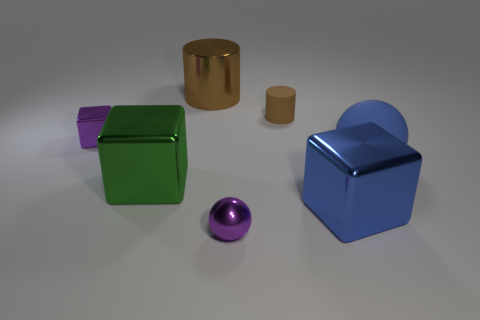Are there any purple cylinders of the same size as the shiny ball?
Your answer should be very brief. No. There is a big blue matte object; is its shape the same as the brown thing that is behind the tiny brown cylinder?
Provide a short and direct response. No. Is there a tiny cylinder to the left of the small shiny thing that is behind the ball that is to the left of the rubber cylinder?
Ensure brevity in your answer.  No. The green shiny block has what size?
Offer a very short reply. Large. What number of other things are there of the same color as the small shiny cube?
Provide a short and direct response. 1. Does the matte object on the left side of the large blue shiny cube have the same shape as the big brown thing?
Make the answer very short. Yes. What color is the other tiny metallic thing that is the same shape as the green shiny object?
Provide a short and direct response. Purple. Is there any other thing that is the same material as the green object?
Offer a terse response. Yes. What size is the other object that is the same shape as the blue rubber thing?
Ensure brevity in your answer.  Small. The object that is both in front of the tiny metallic block and left of the big metal cylinder is made of what material?
Provide a short and direct response. Metal. 